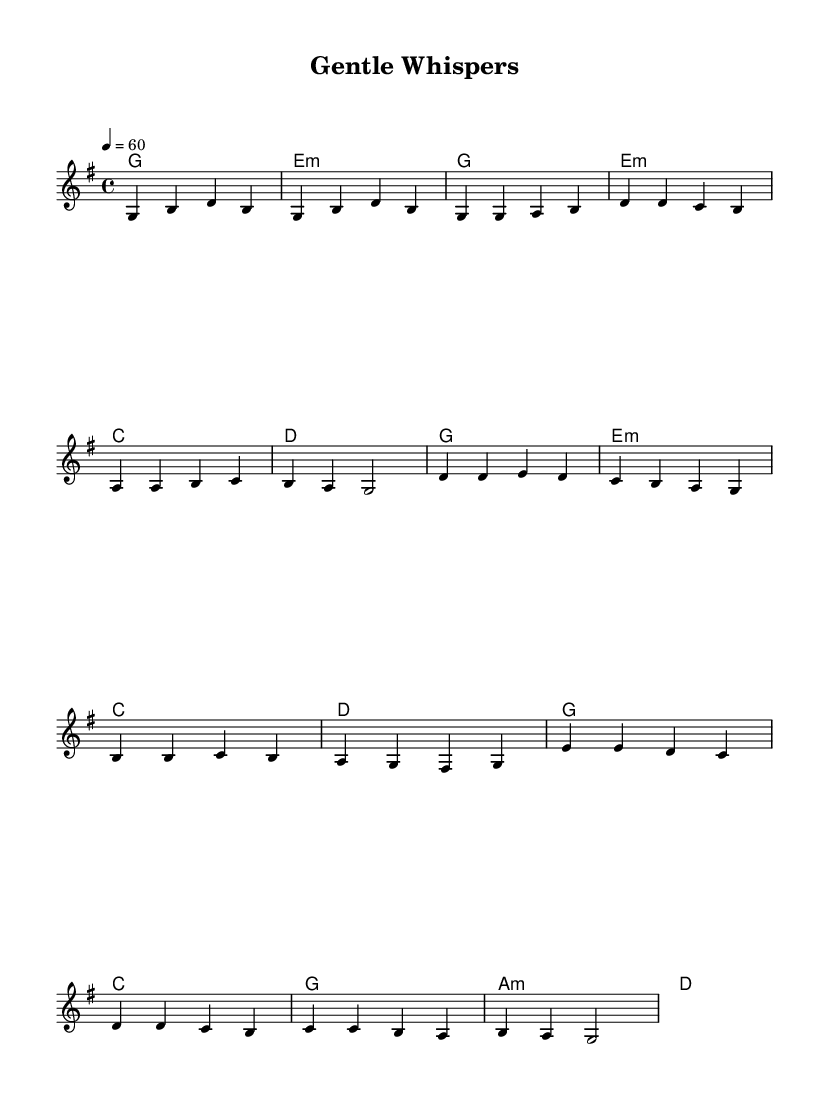What is the key signature of this music? The key signature is G major, which has one sharp (F#) indicated on the staff.
Answer: G major What is the time signature of this music? The time signature is 4/4, meaning there are four beats in each measure, and the quarter note gets one beat.
Answer: 4/4 What is the tempo marking of the piece? The tempo marking is indicated as quarter note equals 60 beats per minute, establishing the pace of the music.
Answer: 60 How many measures are in the verse section? The verse section contains eight measures, as indicated by the four pairs of bar lines in the melody.
Answer: 8 What type of chord follows the “Intro” in the harmonic progression? The chord that follows the “Intro” is E minor, which is the second chord in the sequence.
Answer: E minor Which musical section comes after the "Chorus"? The section that follows the "Chorus" is the "Bridge," as indicated by the progression in the sheet music layout.
Answer: Bridge What is the highest note in the melody? The highest note in the melody is D, which is found in the chorus section, making it the peak pitch in this composition.
Answer: D 